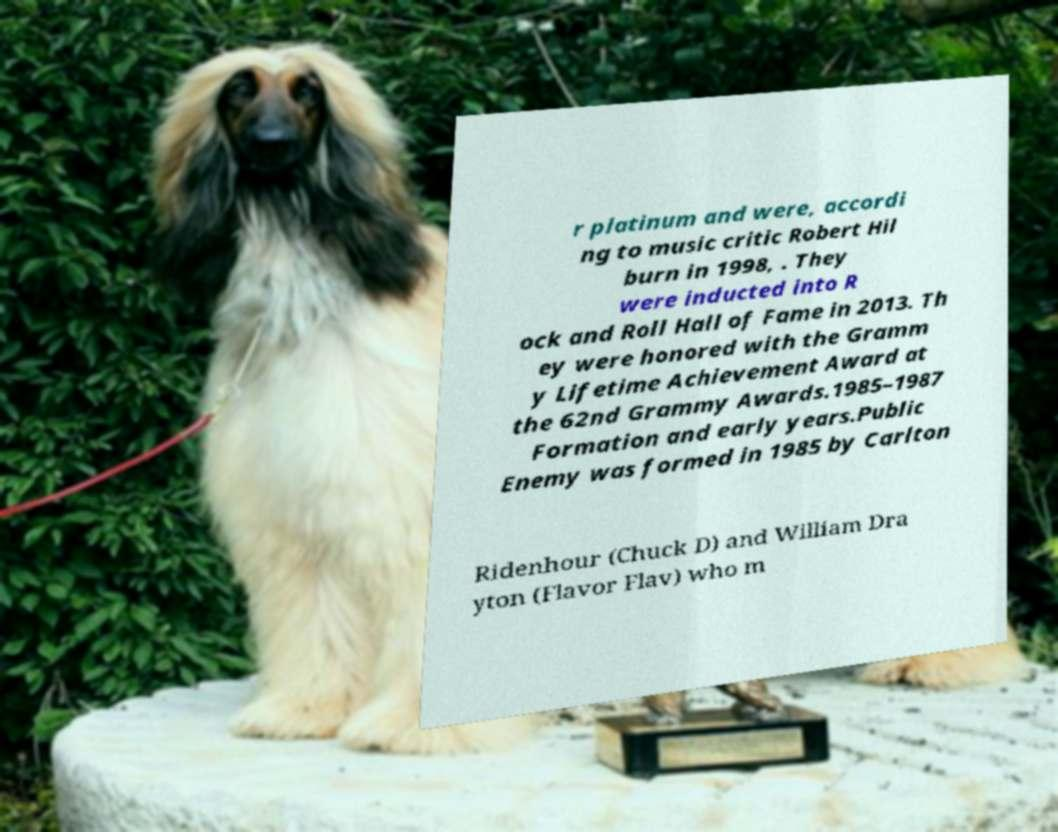For documentation purposes, I need the text within this image transcribed. Could you provide that? r platinum and were, accordi ng to music critic Robert Hil burn in 1998, . They were inducted into R ock and Roll Hall of Fame in 2013. Th ey were honored with the Gramm y Lifetime Achievement Award at the 62nd Grammy Awards.1985–1987 Formation and early years.Public Enemy was formed in 1985 by Carlton Ridenhour (Chuck D) and William Dra yton (Flavor Flav) who m 